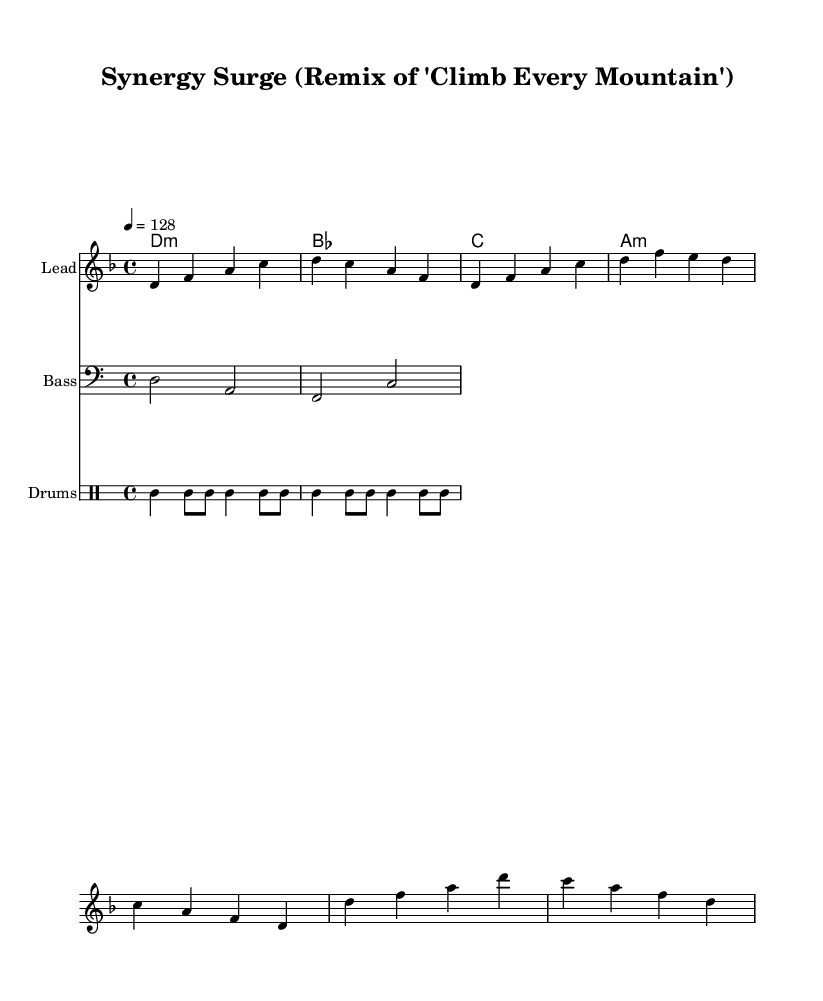What is the key signature of this music? The key signature is indicated by the absence of sharps or flats in the signature section at the beginning of the staff, which corresponds to D minor.
Answer: D minor What is the time signature of this music? The time signature is shown as 4/4 in the notation, indicating there are four beats in each measure.
Answer: 4/4 What is the tempo marking for this piece? The tempo marking is found in the header, indicating that the piece is to be played at a tempo of 128 beats per minute.
Answer: 128 How many measures are in the melody? By counting the measures from the melody section, we can see that there are a total of 6 measures depicted.
Answer: 6 What types of chords are indicated in the harmonies? The chord names indicated show the types as minor for D, A minor, and major for B flat and C, giving a mix of major and minor harmonies throughout the piece.
Answer: Minor and major What instrument is the bass part written for? The bass part is written in bass clef, specifically indicating that it is designed to be played by a bass instrument.
Answer: Bass What is the primary rhythm pattern used in the drum section? The drum section displays a consistent rhythm pattern of bass drum and hi-hat, alternating between different note lengths, emphasizing a dance rhythm.
Answer: Bass and hi-hat 